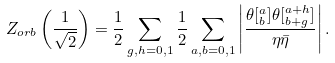Convert formula to latex. <formula><loc_0><loc_0><loc_500><loc_500>Z _ { o r b } \left ( \frac { 1 } { \sqrt { 2 } } \right ) = \frac { 1 } { 2 } \sum _ { g , h = 0 , 1 } \frac { 1 } { 2 } \sum _ { a , b = 0 , 1 } \left | \frac { \theta [ ^ { a } _ { b } ] \theta [ ^ { a + h } _ { b + g } ] } { \eta \bar { \eta } } \right | .</formula> 